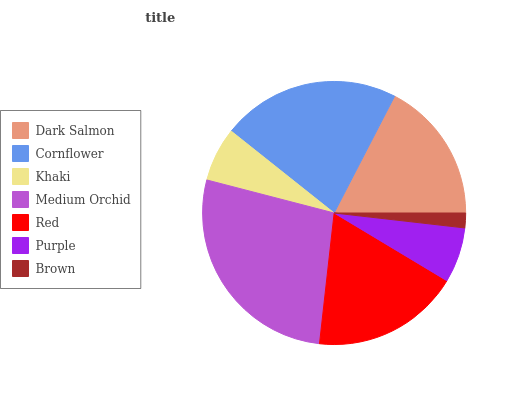Is Brown the minimum?
Answer yes or no. Yes. Is Medium Orchid the maximum?
Answer yes or no. Yes. Is Cornflower the minimum?
Answer yes or no. No. Is Cornflower the maximum?
Answer yes or no. No. Is Cornflower greater than Dark Salmon?
Answer yes or no. Yes. Is Dark Salmon less than Cornflower?
Answer yes or no. Yes. Is Dark Salmon greater than Cornflower?
Answer yes or no. No. Is Cornflower less than Dark Salmon?
Answer yes or no. No. Is Dark Salmon the high median?
Answer yes or no. Yes. Is Dark Salmon the low median?
Answer yes or no. Yes. Is Red the high median?
Answer yes or no. No. Is Purple the low median?
Answer yes or no. No. 